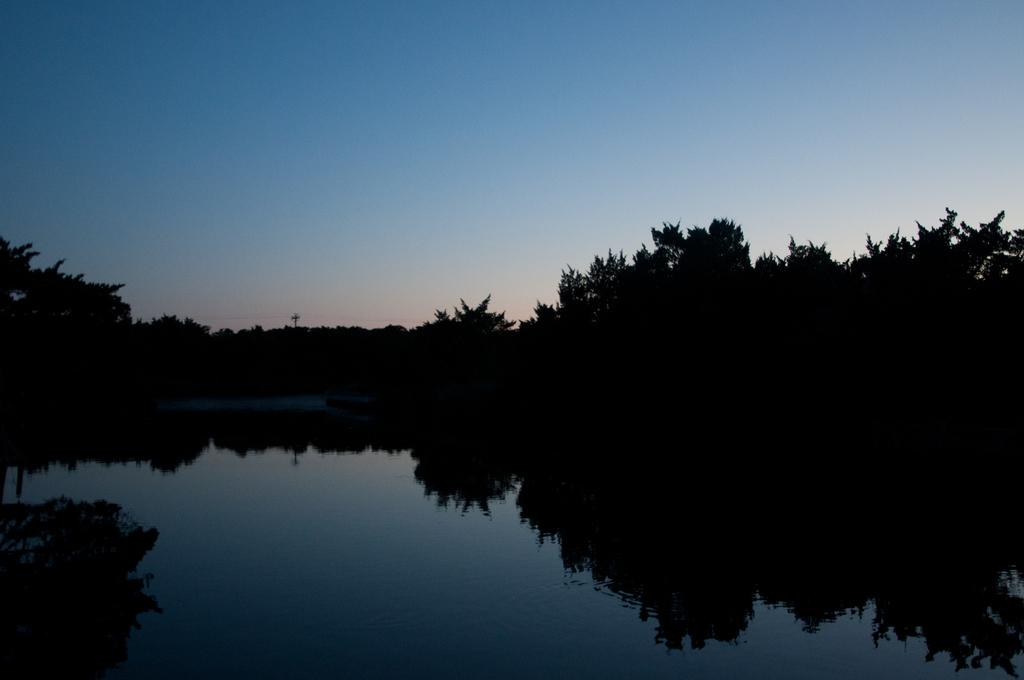Where was the image taken? The image is taken outdoors. What can be seen at the top of the image? The sky is visible at the top of the image. What is located at the bottom of the image? There is a pond at the bottom of the image. What type of vegetation is present in the middle of the image? There are many trees and plants in the middle of the image. What type of office can be seen in the image? There is no office present in the image; it is an outdoor scene with a pond, sky, and vegetation. 